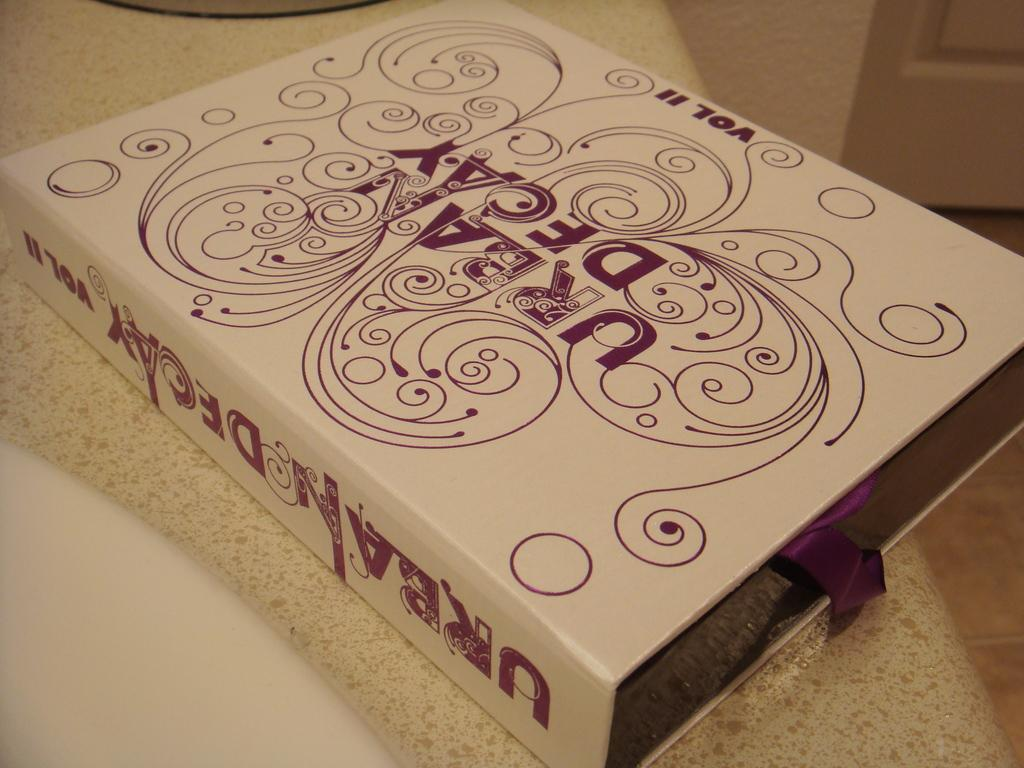<image>
Present a compact description of the photo's key features. An Urban Decay makeup box that includes volume II 